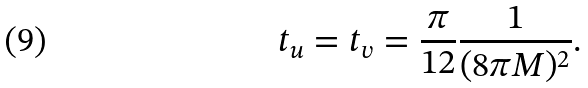<formula> <loc_0><loc_0><loc_500><loc_500>t _ { u } = t _ { v } = \frac { \pi } { 1 2 } \frac { 1 } { ( 8 \pi M ) ^ { 2 } } .</formula> 